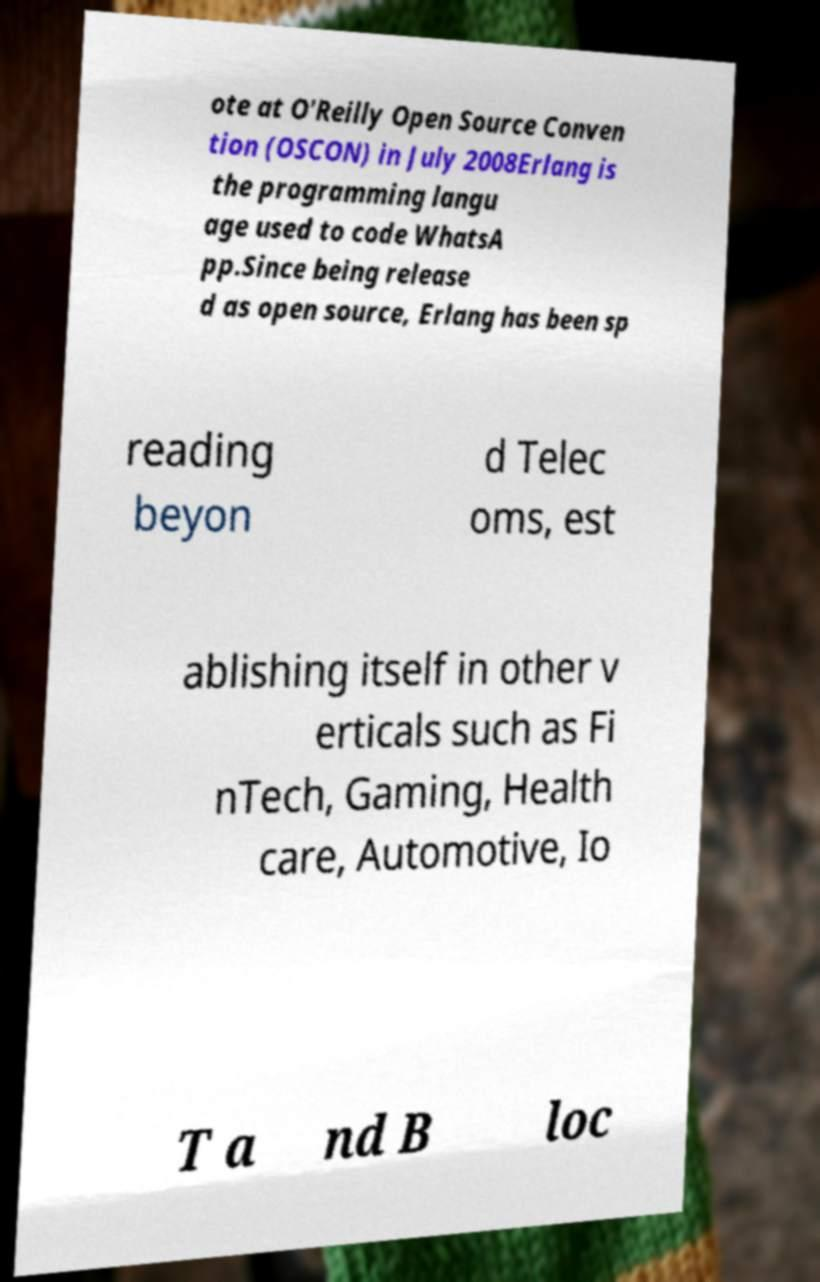Could you assist in decoding the text presented in this image and type it out clearly? ote at O'Reilly Open Source Conven tion (OSCON) in July 2008Erlang is the programming langu age used to code WhatsA pp.Since being release d as open source, Erlang has been sp reading beyon d Telec oms, est ablishing itself in other v erticals such as Fi nTech, Gaming, Health care, Automotive, Io T a nd B loc 